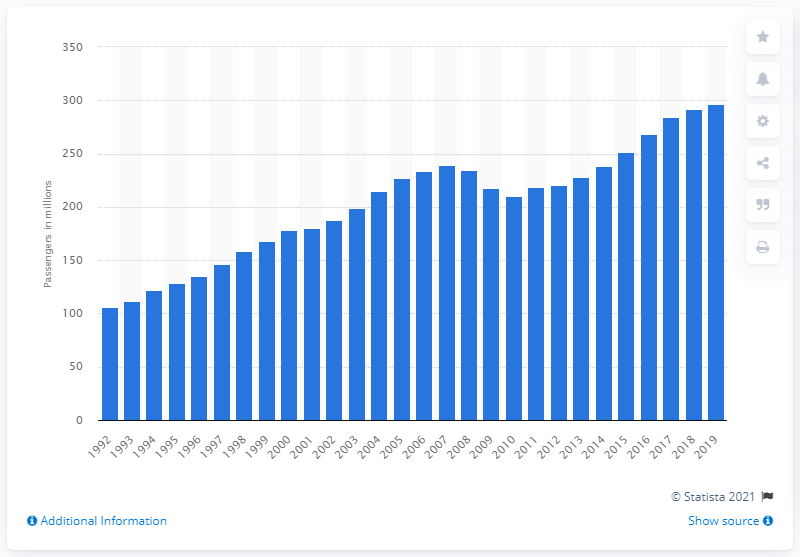Identify some key points in this picture. In 1992, a total of 105,660 passengers arrived and departed from airport terminals in the UK. During the period of 1992 to 2019, the number of passengers arriving and departing at airport terminals in the UK fluctuated, with a total of 296.66 million passengers. 